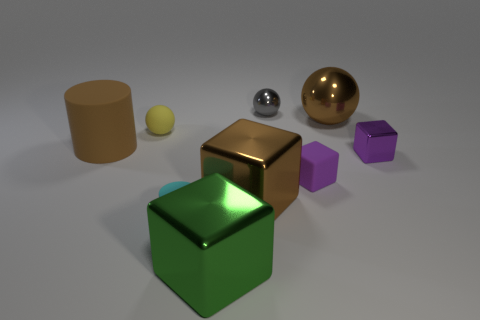There is a matte thing that is behind the large cylinder; is its shape the same as the big metal thing behind the tiny matte ball?
Keep it short and to the point. Yes. How many other objects are the same size as the gray shiny sphere?
Offer a terse response. 4. What size is the brown matte cylinder?
Your answer should be very brief. Large. Does the tiny cube on the left side of the purple metallic cube have the same material as the tiny yellow ball?
Ensure brevity in your answer.  Yes. What color is the other rubber object that is the same shape as the cyan rubber object?
Ensure brevity in your answer.  Brown. Does the rubber object to the left of the yellow thing have the same color as the big ball?
Your response must be concise. Yes. Are there any big brown shiny objects in front of the big brown ball?
Your answer should be very brief. Yes. The tiny thing that is both in front of the yellow matte thing and behind the purple rubber thing is what color?
Provide a short and direct response. Purple. There is a metal thing that is the same color as the tiny matte block; what shape is it?
Offer a very short reply. Cube. What size is the brown object left of the shiny object in front of the cyan rubber thing?
Keep it short and to the point. Large. 